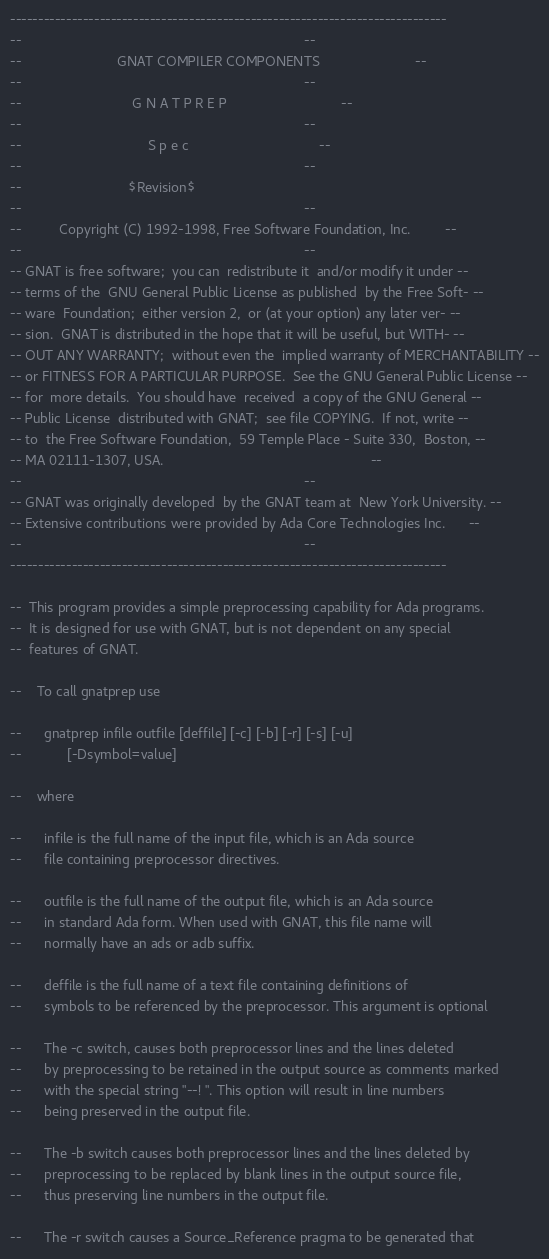Convert code to text. <code><loc_0><loc_0><loc_500><loc_500><_Ada_>------------------------------------------------------------------------------
--                                                                          --
--                         GNAT COMPILER COMPONENTS                         --
--                                                                          --
--                             G N A T P R E P                              --
--                                                                          --
--                                 S p e c                                  --
--                                                                          --
--                            $Revision$
--                                                                          --
--          Copyright (C) 1992-1998, Free Software Foundation, Inc.         --
--                                                                          --
-- GNAT is free software;  you can  redistribute it  and/or modify it under --
-- terms of the  GNU General Public License as published  by the Free Soft- --
-- ware  Foundation;  either version 2,  or (at your option) any later ver- --
-- sion.  GNAT is distributed in the hope that it will be useful, but WITH- --
-- OUT ANY WARRANTY;  without even the  implied warranty of MERCHANTABILITY --
-- or FITNESS FOR A PARTICULAR PURPOSE.  See the GNU General Public License --
-- for  more details.  You should have  received  a copy of the GNU General --
-- Public License  distributed with GNAT;  see file COPYING.  If not, write --
-- to  the Free Software Foundation,  59 Temple Place - Suite 330,  Boston, --
-- MA 02111-1307, USA.                                                      --
--                                                                          --
-- GNAT was originally developed  by the GNAT team at  New York University. --
-- Extensive contributions were provided by Ada Core Technologies Inc.      --
--                                                                          --
------------------------------------------------------------------------------

--  This program provides a simple preprocessing capability for Ada programs.
--  It is designed for use with GNAT, but is not dependent on any special
--  features of GNAT.

--    To call gnatprep use

--      gnatprep infile outfile [deffile] [-c] [-b] [-r] [-s] [-u]
--            [-Dsymbol=value]

--    where

--      infile is the full name of the input file, which is an Ada source
--      file containing preprocessor directives.

--      outfile is the full name of the output file, which is an Ada source
--      in standard Ada form. When used with GNAT, this file name will
--      normally have an ads or adb suffix.

--      deffile is the full name of a text file containing definitions of
--      symbols to be referenced by the preprocessor. This argument is optional

--      The -c switch, causes both preprocessor lines and the lines deleted
--      by preprocessing to be retained in the output source as comments marked
--      with the special string "--! ". This option will result in line numbers
--      being preserved in the output file.

--      The -b switch causes both preprocessor lines and the lines deleted by
--      preprocessing to be replaced by blank lines in the output source file,
--      thus preserving line numbers in the output file.

--      The -r switch causes a Source_Reference pragma to be generated that</code> 